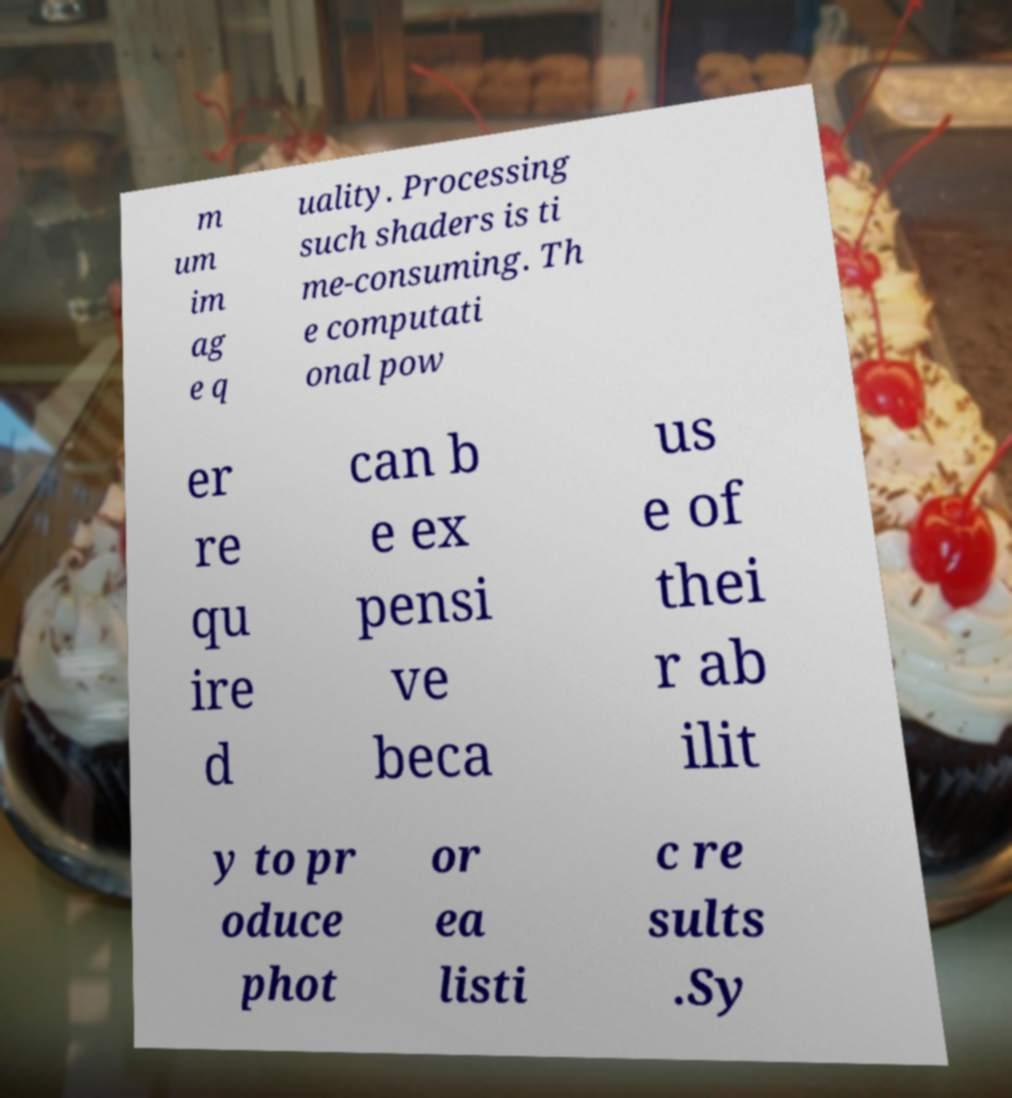I need the written content from this picture converted into text. Can you do that? m um im ag e q uality. Processing such shaders is ti me-consuming. Th e computati onal pow er re qu ire d can b e ex pensi ve beca us e of thei r ab ilit y to pr oduce phot or ea listi c re sults .Sy 